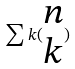Convert formula to latex. <formula><loc_0><loc_0><loc_500><loc_500>\sum k ( \begin{matrix} n \\ k \end{matrix} )</formula> 